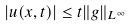<formula> <loc_0><loc_0><loc_500><loc_500>| u ( x , t ) | \leq t \| g \| _ { L ^ { \infty } }</formula> 